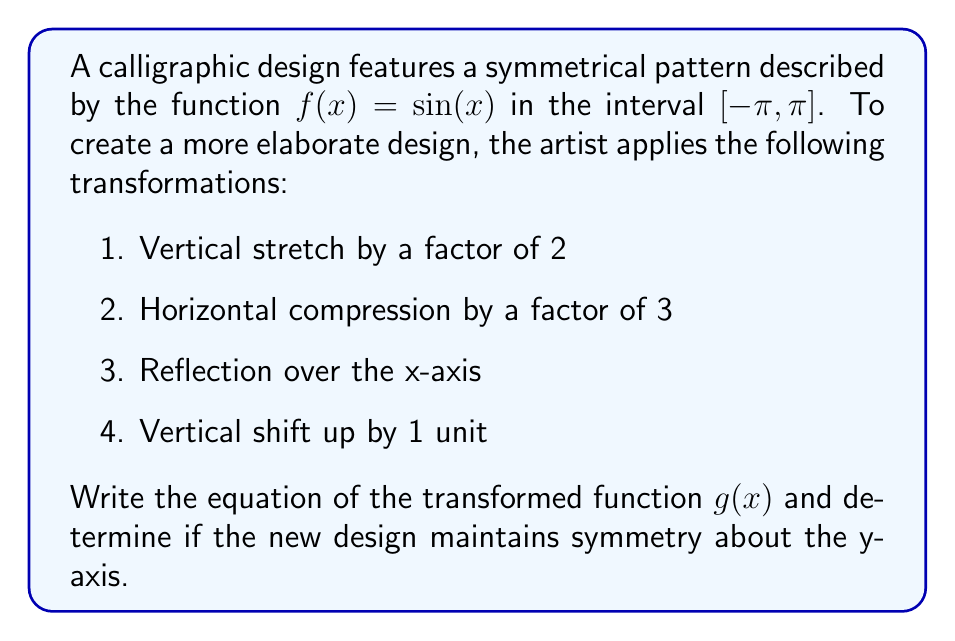Give your solution to this math problem. Let's apply the transformations step by step:

1. Vertical stretch by a factor of 2:
   $f_1(x) = 2\sin(x)$

2. Horizontal compression by a factor of 3:
   $f_2(x) = 2\sin(3x)$

3. Reflection over the x-axis:
   $f_3(x) = -2\sin(3x)$

4. Vertical shift up by 1 unit:
   $g(x) = -2\sin(3x) + 1$

To determine if the new function $g(x)$ is symmetric about the y-axis, we need to check if $g(x) = g(-x)$ for all $x$ in the domain:

$g(x) = -2\sin(3x) + 1$
$g(-x) = -2\sin(3(-x)) + 1 = -2\sin(-3x) + 1 = 2\sin(3x) + 1$

Since $g(x) \neq g(-x)$, the new design does not maintain symmetry about the y-axis.

However, it's worth noting that the transformed function does have symmetry about the x-axis, as it's an even function:

$g(-x) = -2\sin(-3x) + 1 = 2\sin(3x) + 1$
$g(x) = -2\sin(3x) + 1$

The sum of these two equations gives:
$g(x) + g(-x) = 2$

This constant sum indicates symmetry about the line $y = 1$, which is a horizontal line of reflection for the transformed design.
Answer: $g(x) = -2\sin(3x) + 1$; Not symmetric about y-axis 